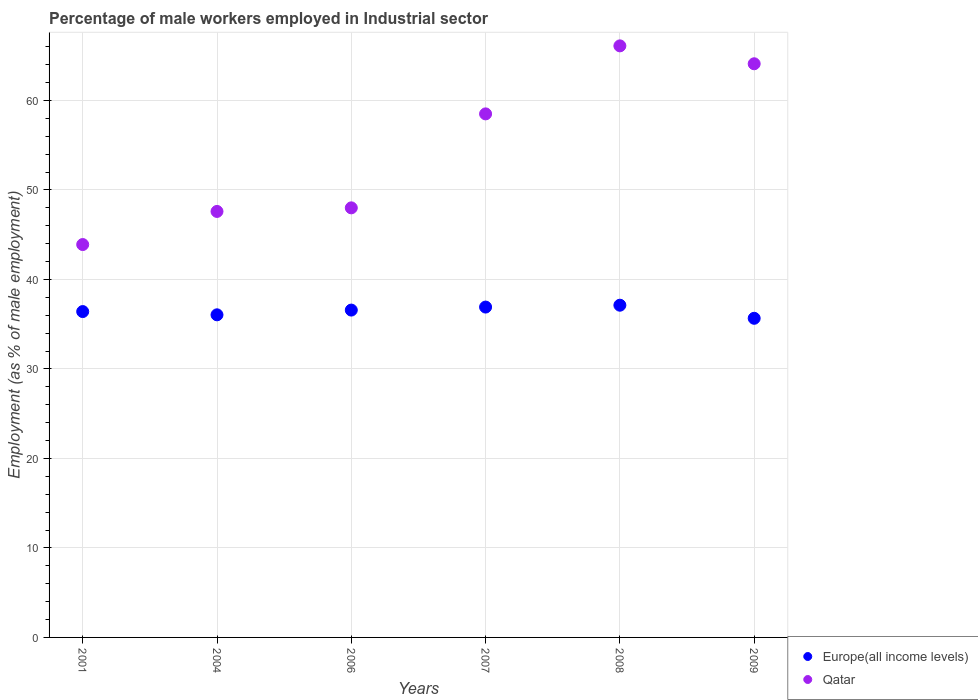How many different coloured dotlines are there?
Give a very brief answer. 2. Is the number of dotlines equal to the number of legend labels?
Your answer should be very brief. Yes. What is the percentage of male workers employed in Industrial sector in Europe(all income levels) in 2007?
Offer a terse response. 36.91. Across all years, what is the maximum percentage of male workers employed in Industrial sector in Europe(all income levels)?
Offer a terse response. 37.12. Across all years, what is the minimum percentage of male workers employed in Industrial sector in Qatar?
Provide a succinct answer. 43.9. In which year was the percentage of male workers employed in Industrial sector in Qatar minimum?
Keep it short and to the point. 2001. What is the total percentage of male workers employed in Industrial sector in Qatar in the graph?
Provide a succinct answer. 328.2. What is the difference between the percentage of male workers employed in Industrial sector in Qatar in 2001 and that in 2008?
Keep it short and to the point. -22.2. What is the difference between the percentage of male workers employed in Industrial sector in Qatar in 2009 and the percentage of male workers employed in Industrial sector in Europe(all income levels) in 2007?
Keep it short and to the point. 27.19. What is the average percentage of male workers employed in Industrial sector in Europe(all income levels) per year?
Make the answer very short. 36.46. In the year 2007, what is the difference between the percentage of male workers employed in Industrial sector in Europe(all income levels) and percentage of male workers employed in Industrial sector in Qatar?
Your answer should be compact. -21.59. In how many years, is the percentage of male workers employed in Industrial sector in Europe(all income levels) greater than 42 %?
Your response must be concise. 0. What is the ratio of the percentage of male workers employed in Industrial sector in Qatar in 2001 to that in 2007?
Give a very brief answer. 0.75. Is the percentage of male workers employed in Industrial sector in Europe(all income levels) in 2006 less than that in 2007?
Provide a short and direct response. Yes. What is the difference between the highest and the second highest percentage of male workers employed in Industrial sector in Europe(all income levels)?
Make the answer very short. 0.21. What is the difference between the highest and the lowest percentage of male workers employed in Industrial sector in Qatar?
Offer a very short reply. 22.2. Is the sum of the percentage of male workers employed in Industrial sector in Europe(all income levels) in 2007 and 2009 greater than the maximum percentage of male workers employed in Industrial sector in Qatar across all years?
Offer a very short reply. Yes. Does the percentage of male workers employed in Industrial sector in Qatar monotonically increase over the years?
Your response must be concise. No. Is the percentage of male workers employed in Industrial sector in Europe(all income levels) strictly greater than the percentage of male workers employed in Industrial sector in Qatar over the years?
Provide a short and direct response. No. Is the percentage of male workers employed in Industrial sector in Europe(all income levels) strictly less than the percentage of male workers employed in Industrial sector in Qatar over the years?
Ensure brevity in your answer.  Yes. How many dotlines are there?
Make the answer very short. 2. How many years are there in the graph?
Keep it short and to the point. 6. What is the difference between two consecutive major ticks on the Y-axis?
Provide a short and direct response. 10. Does the graph contain any zero values?
Make the answer very short. No. How many legend labels are there?
Make the answer very short. 2. How are the legend labels stacked?
Give a very brief answer. Vertical. What is the title of the graph?
Your answer should be compact. Percentage of male workers employed in Industrial sector. What is the label or title of the Y-axis?
Give a very brief answer. Employment (as % of male employment). What is the Employment (as % of male employment) in Europe(all income levels) in 2001?
Your answer should be very brief. 36.41. What is the Employment (as % of male employment) in Qatar in 2001?
Ensure brevity in your answer.  43.9. What is the Employment (as % of male employment) in Europe(all income levels) in 2004?
Provide a succinct answer. 36.05. What is the Employment (as % of male employment) in Qatar in 2004?
Your response must be concise. 47.6. What is the Employment (as % of male employment) in Europe(all income levels) in 2006?
Offer a very short reply. 36.58. What is the Employment (as % of male employment) of Europe(all income levels) in 2007?
Provide a succinct answer. 36.91. What is the Employment (as % of male employment) of Qatar in 2007?
Your answer should be very brief. 58.5. What is the Employment (as % of male employment) in Europe(all income levels) in 2008?
Your answer should be compact. 37.12. What is the Employment (as % of male employment) of Qatar in 2008?
Your response must be concise. 66.1. What is the Employment (as % of male employment) of Europe(all income levels) in 2009?
Make the answer very short. 35.66. What is the Employment (as % of male employment) of Qatar in 2009?
Provide a short and direct response. 64.1. Across all years, what is the maximum Employment (as % of male employment) in Europe(all income levels)?
Keep it short and to the point. 37.12. Across all years, what is the maximum Employment (as % of male employment) in Qatar?
Your response must be concise. 66.1. Across all years, what is the minimum Employment (as % of male employment) of Europe(all income levels)?
Offer a terse response. 35.66. Across all years, what is the minimum Employment (as % of male employment) of Qatar?
Offer a very short reply. 43.9. What is the total Employment (as % of male employment) of Europe(all income levels) in the graph?
Provide a succinct answer. 218.73. What is the total Employment (as % of male employment) in Qatar in the graph?
Make the answer very short. 328.2. What is the difference between the Employment (as % of male employment) in Europe(all income levels) in 2001 and that in 2004?
Provide a short and direct response. 0.36. What is the difference between the Employment (as % of male employment) of Europe(all income levels) in 2001 and that in 2007?
Your response must be concise. -0.5. What is the difference between the Employment (as % of male employment) of Qatar in 2001 and that in 2007?
Offer a very short reply. -14.6. What is the difference between the Employment (as % of male employment) of Europe(all income levels) in 2001 and that in 2008?
Offer a very short reply. -0.71. What is the difference between the Employment (as % of male employment) of Qatar in 2001 and that in 2008?
Offer a terse response. -22.2. What is the difference between the Employment (as % of male employment) in Europe(all income levels) in 2001 and that in 2009?
Ensure brevity in your answer.  0.75. What is the difference between the Employment (as % of male employment) of Qatar in 2001 and that in 2009?
Your answer should be very brief. -20.2. What is the difference between the Employment (as % of male employment) in Europe(all income levels) in 2004 and that in 2006?
Make the answer very short. -0.53. What is the difference between the Employment (as % of male employment) in Europe(all income levels) in 2004 and that in 2007?
Offer a terse response. -0.87. What is the difference between the Employment (as % of male employment) in Europe(all income levels) in 2004 and that in 2008?
Keep it short and to the point. -1.07. What is the difference between the Employment (as % of male employment) of Qatar in 2004 and that in 2008?
Your response must be concise. -18.5. What is the difference between the Employment (as % of male employment) in Europe(all income levels) in 2004 and that in 2009?
Provide a short and direct response. 0.39. What is the difference between the Employment (as % of male employment) in Qatar in 2004 and that in 2009?
Give a very brief answer. -16.5. What is the difference between the Employment (as % of male employment) of Europe(all income levels) in 2006 and that in 2007?
Your response must be concise. -0.34. What is the difference between the Employment (as % of male employment) in Europe(all income levels) in 2006 and that in 2008?
Your response must be concise. -0.54. What is the difference between the Employment (as % of male employment) of Qatar in 2006 and that in 2008?
Your answer should be very brief. -18.1. What is the difference between the Employment (as % of male employment) of Europe(all income levels) in 2006 and that in 2009?
Provide a short and direct response. 0.92. What is the difference between the Employment (as % of male employment) in Qatar in 2006 and that in 2009?
Make the answer very short. -16.1. What is the difference between the Employment (as % of male employment) of Europe(all income levels) in 2007 and that in 2008?
Offer a terse response. -0.21. What is the difference between the Employment (as % of male employment) of Qatar in 2007 and that in 2008?
Offer a terse response. -7.6. What is the difference between the Employment (as % of male employment) in Europe(all income levels) in 2007 and that in 2009?
Ensure brevity in your answer.  1.25. What is the difference between the Employment (as % of male employment) of Qatar in 2007 and that in 2009?
Make the answer very short. -5.6. What is the difference between the Employment (as % of male employment) in Europe(all income levels) in 2008 and that in 2009?
Keep it short and to the point. 1.46. What is the difference between the Employment (as % of male employment) of Qatar in 2008 and that in 2009?
Make the answer very short. 2. What is the difference between the Employment (as % of male employment) in Europe(all income levels) in 2001 and the Employment (as % of male employment) in Qatar in 2004?
Offer a very short reply. -11.19. What is the difference between the Employment (as % of male employment) of Europe(all income levels) in 2001 and the Employment (as % of male employment) of Qatar in 2006?
Your answer should be compact. -11.59. What is the difference between the Employment (as % of male employment) of Europe(all income levels) in 2001 and the Employment (as % of male employment) of Qatar in 2007?
Give a very brief answer. -22.09. What is the difference between the Employment (as % of male employment) of Europe(all income levels) in 2001 and the Employment (as % of male employment) of Qatar in 2008?
Your response must be concise. -29.69. What is the difference between the Employment (as % of male employment) in Europe(all income levels) in 2001 and the Employment (as % of male employment) in Qatar in 2009?
Your response must be concise. -27.69. What is the difference between the Employment (as % of male employment) of Europe(all income levels) in 2004 and the Employment (as % of male employment) of Qatar in 2006?
Offer a very short reply. -11.95. What is the difference between the Employment (as % of male employment) of Europe(all income levels) in 2004 and the Employment (as % of male employment) of Qatar in 2007?
Provide a succinct answer. -22.45. What is the difference between the Employment (as % of male employment) of Europe(all income levels) in 2004 and the Employment (as % of male employment) of Qatar in 2008?
Keep it short and to the point. -30.05. What is the difference between the Employment (as % of male employment) in Europe(all income levels) in 2004 and the Employment (as % of male employment) in Qatar in 2009?
Provide a succinct answer. -28.05. What is the difference between the Employment (as % of male employment) of Europe(all income levels) in 2006 and the Employment (as % of male employment) of Qatar in 2007?
Make the answer very short. -21.92. What is the difference between the Employment (as % of male employment) of Europe(all income levels) in 2006 and the Employment (as % of male employment) of Qatar in 2008?
Your answer should be very brief. -29.52. What is the difference between the Employment (as % of male employment) of Europe(all income levels) in 2006 and the Employment (as % of male employment) of Qatar in 2009?
Offer a very short reply. -27.52. What is the difference between the Employment (as % of male employment) of Europe(all income levels) in 2007 and the Employment (as % of male employment) of Qatar in 2008?
Keep it short and to the point. -29.19. What is the difference between the Employment (as % of male employment) in Europe(all income levels) in 2007 and the Employment (as % of male employment) in Qatar in 2009?
Your response must be concise. -27.19. What is the difference between the Employment (as % of male employment) in Europe(all income levels) in 2008 and the Employment (as % of male employment) in Qatar in 2009?
Keep it short and to the point. -26.98. What is the average Employment (as % of male employment) in Europe(all income levels) per year?
Provide a succinct answer. 36.46. What is the average Employment (as % of male employment) of Qatar per year?
Your response must be concise. 54.7. In the year 2001, what is the difference between the Employment (as % of male employment) in Europe(all income levels) and Employment (as % of male employment) in Qatar?
Your answer should be compact. -7.49. In the year 2004, what is the difference between the Employment (as % of male employment) of Europe(all income levels) and Employment (as % of male employment) of Qatar?
Offer a very short reply. -11.55. In the year 2006, what is the difference between the Employment (as % of male employment) in Europe(all income levels) and Employment (as % of male employment) in Qatar?
Give a very brief answer. -11.42. In the year 2007, what is the difference between the Employment (as % of male employment) in Europe(all income levels) and Employment (as % of male employment) in Qatar?
Give a very brief answer. -21.59. In the year 2008, what is the difference between the Employment (as % of male employment) of Europe(all income levels) and Employment (as % of male employment) of Qatar?
Offer a very short reply. -28.98. In the year 2009, what is the difference between the Employment (as % of male employment) of Europe(all income levels) and Employment (as % of male employment) of Qatar?
Your answer should be very brief. -28.44. What is the ratio of the Employment (as % of male employment) of Europe(all income levels) in 2001 to that in 2004?
Give a very brief answer. 1.01. What is the ratio of the Employment (as % of male employment) of Qatar in 2001 to that in 2004?
Your answer should be very brief. 0.92. What is the ratio of the Employment (as % of male employment) of Europe(all income levels) in 2001 to that in 2006?
Make the answer very short. 1. What is the ratio of the Employment (as % of male employment) of Qatar in 2001 to that in 2006?
Offer a terse response. 0.91. What is the ratio of the Employment (as % of male employment) of Europe(all income levels) in 2001 to that in 2007?
Provide a succinct answer. 0.99. What is the ratio of the Employment (as % of male employment) in Qatar in 2001 to that in 2007?
Your answer should be very brief. 0.75. What is the ratio of the Employment (as % of male employment) in Europe(all income levels) in 2001 to that in 2008?
Give a very brief answer. 0.98. What is the ratio of the Employment (as % of male employment) of Qatar in 2001 to that in 2008?
Offer a very short reply. 0.66. What is the ratio of the Employment (as % of male employment) in Europe(all income levels) in 2001 to that in 2009?
Offer a terse response. 1.02. What is the ratio of the Employment (as % of male employment) in Qatar in 2001 to that in 2009?
Ensure brevity in your answer.  0.68. What is the ratio of the Employment (as % of male employment) in Europe(all income levels) in 2004 to that in 2006?
Provide a short and direct response. 0.99. What is the ratio of the Employment (as % of male employment) of Europe(all income levels) in 2004 to that in 2007?
Your response must be concise. 0.98. What is the ratio of the Employment (as % of male employment) in Qatar in 2004 to that in 2007?
Offer a terse response. 0.81. What is the ratio of the Employment (as % of male employment) of Europe(all income levels) in 2004 to that in 2008?
Your answer should be compact. 0.97. What is the ratio of the Employment (as % of male employment) in Qatar in 2004 to that in 2008?
Ensure brevity in your answer.  0.72. What is the ratio of the Employment (as % of male employment) of Europe(all income levels) in 2004 to that in 2009?
Your response must be concise. 1.01. What is the ratio of the Employment (as % of male employment) of Qatar in 2004 to that in 2009?
Make the answer very short. 0.74. What is the ratio of the Employment (as % of male employment) in Europe(all income levels) in 2006 to that in 2007?
Provide a succinct answer. 0.99. What is the ratio of the Employment (as % of male employment) in Qatar in 2006 to that in 2007?
Make the answer very short. 0.82. What is the ratio of the Employment (as % of male employment) in Europe(all income levels) in 2006 to that in 2008?
Offer a very short reply. 0.99. What is the ratio of the Employment (as % of male employment) of Qatar in 2006 to that in 2008?
Offer a very short reply. 0.73. What is the ratio of the Employment (as % of male employment) in Europe(all income levels) in 2006 to that in 2009?
Provide a short and direct response. 1.03. What is the ratio of the Employment (as % of male employment) in Qatar in 2006 to that in 2009?
Offer a terse response. 0.75. What is the ratio of the Employment (as % of male employment) in Qatar in 2007 to that in 2008?
Your answer should be compact. 0.89. What is the ratio of the Employment (as % of male employment) in Europe(all income levels) in 2007 to that in 2009?
Ensure brevity in your answer.  1.04. What is the ratio of the Employment (as % of male employment) in Qatar in 2007 to that in 2009?
Ensure brevity in your answer.  0.91. What is the ratio of the Employment (as % of male employment) in Europe(all income levels) in 2008 to that in 2009?
Make the answer very short. 1.04. What is the ratio of the Employment (as % of male employment) of Qatar in 2008 to that in 2009?
Give a very brief answer. 1.03. What is the difference between the highest and the second highest Employment (as % of male employment) of Europe(all income levels)?
Ensure brevity in your answer.  0.21. What is the difference between the highest and the lowest Employment (as % of male employment) in Europe(all income levels)?
Make the answer very short. 1.46. 